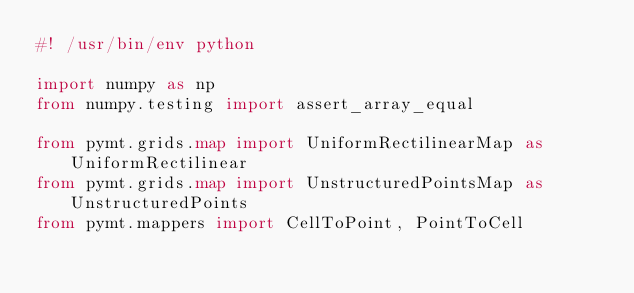<code> <loc_0><loc_0><loc_500><loc_500><_Python_>#! /usr/bin/env python

import numpy as np
from numpy.testing import assert_array_equal

from pymt.grids.map import UniformRectilinearMap as UniformRectilinear
from pymt.grids.map import UnstructuredPointsMap as UnstructuredPoints
from pymt.mappers import CellToPoint, PointToCell

</code> 